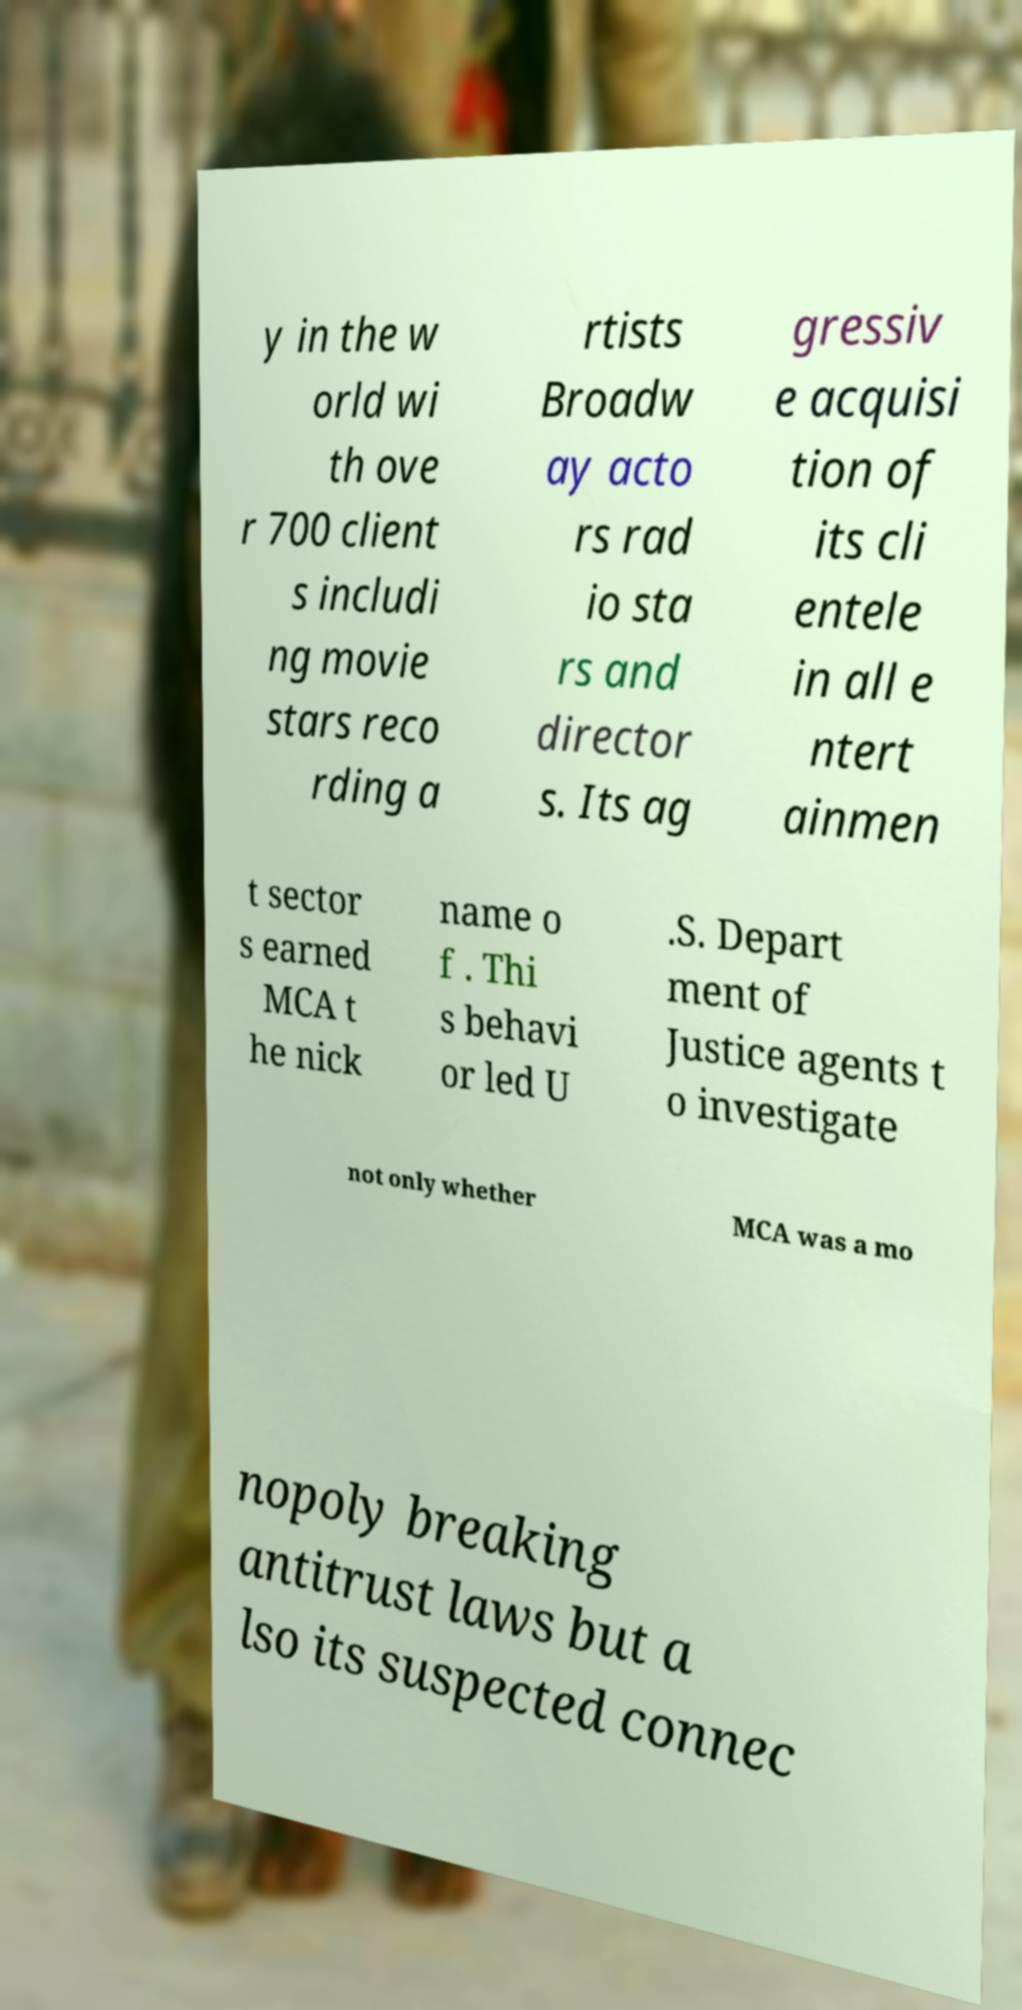I need the written content from this picture converted into text. Can you do that? y in the w orld wi th ove r 700 client s includi ng movie stars reco rding a rtists Broadw ay acto rs rad io sta rs and director s. Its ag gressiv e acquisi tion of its cli entele in all e ntert ainmen t sector s earned MCA t he nick name o f . Thi s behavi or led U .S. Depart ment of Justice agents t o investigate not only whether MCA was a mo nopoly breaking antitrust laws but a lso its suspected connec 